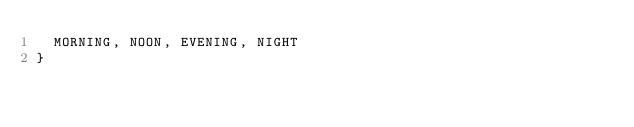Convert code to text. <code><loc_0><loc_0><loc_500><loc_500><_Kotlin_>  MORNING, NOON, EVENING, NIGHT
}</code> 